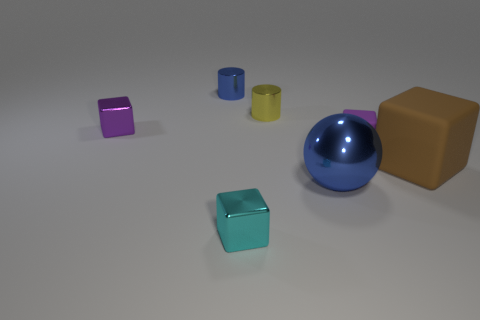There is a purple matte block; are there any tiny blocks behind it?
Offer a terse response. Yes. Is the number of metal blocks that are behind the large brown rubber object the same as the number of large cubes?
Give a very brief answer. Yes. What size is the blue thing that is the same shape as the yellow metal object?
Offer a terse response. Small. Is the shape of the small purple metallic thing the same as the large blue thing behind the small cyan block?
Provide a short and direct response. No. What size is the blue metal thing in front of the blue metal thing that is behind the large blue metal ball?
Provide a short and direct response. Large. Is the number of big blue shiny spheres that are behind the small yellow shiny cylinder the same as the number of balls that are left of the cyan block?
Your answer should be compact. Yes. There is another thing that is the same shape as the yellow metal object; what color is it?
Provide a succinct answer. Blue. How many small metal cylinders have the same color as the ball?
Make the answer very short. 1. There is a purple thing left of the yellow metallic cylinder; is it the same shape as the small blue shiny object?
Give a very brief answer. No. There is a blue metallic object left of the blue metal thing in front of the yellow shiny cylinder that is behind the big brown cube; what is its shape?
Your answer should be compact. Cylinder. 